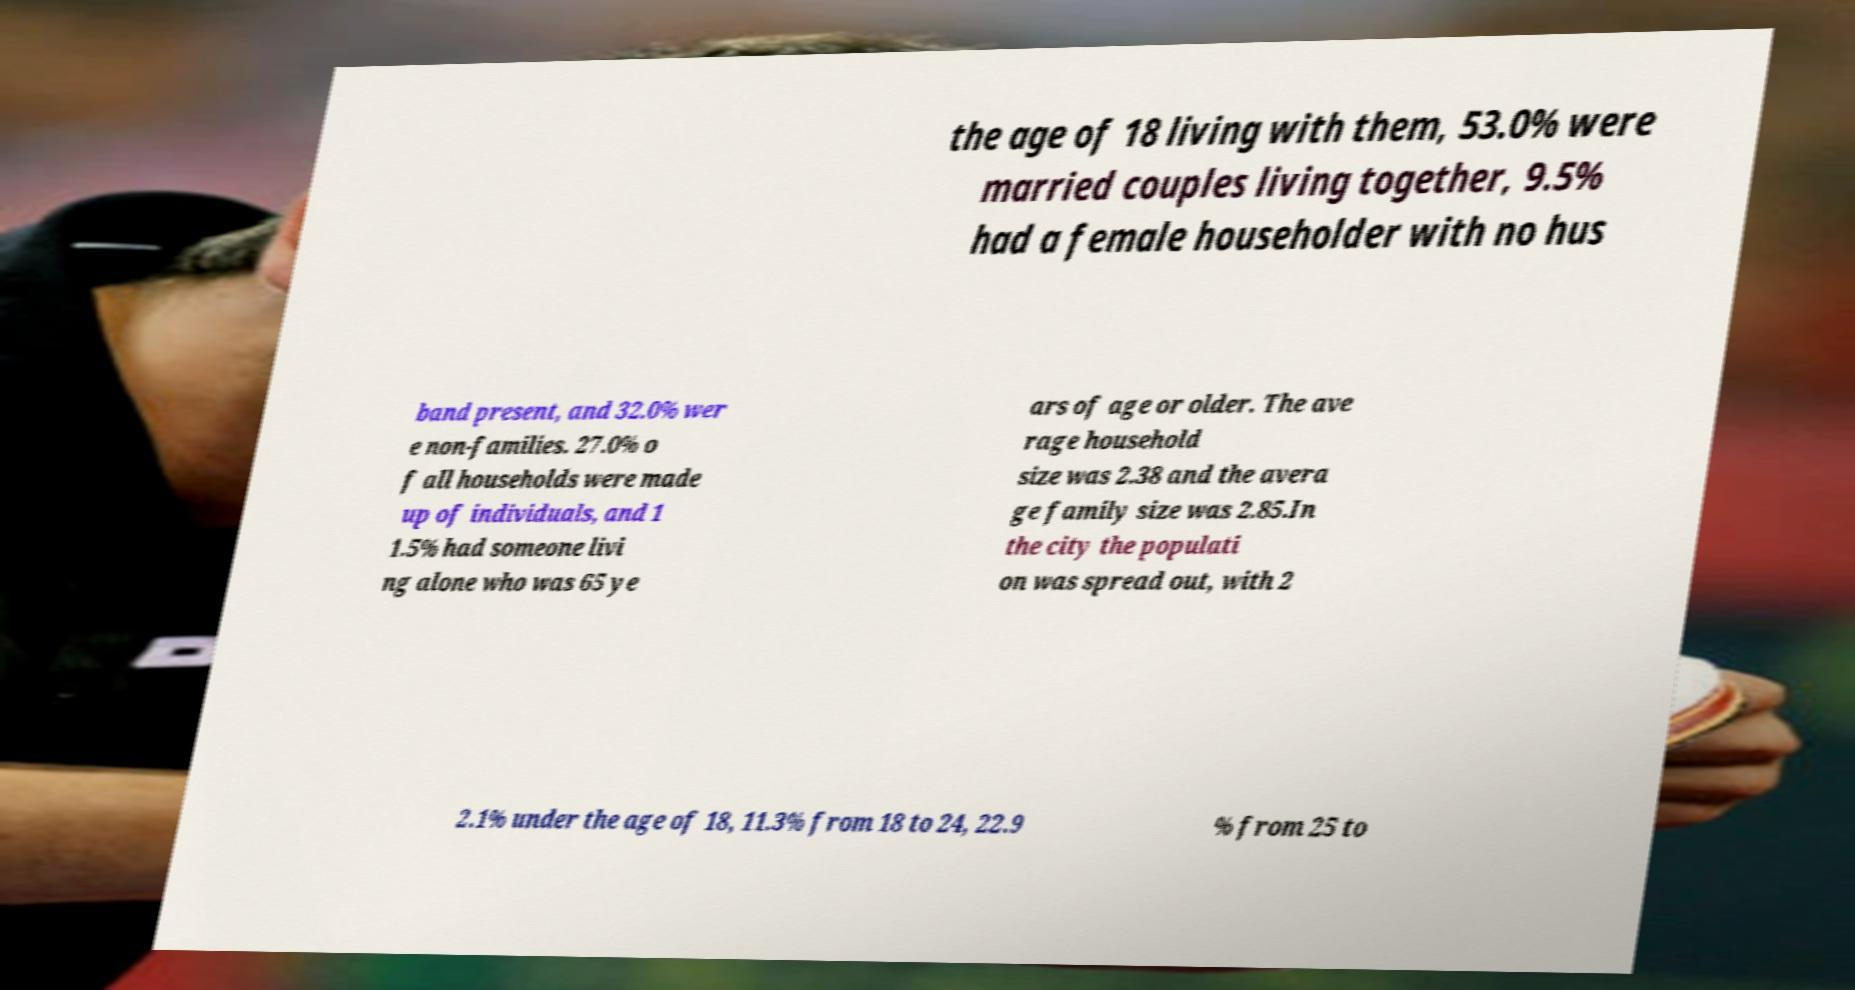I need the written content from this picture converted into text. Can you do that? the age of 18 living with them, 53.0% were married couples living together, 9.5% had a female householder with no hus band present, and 32.0% wer e non-families. 27.0% o f all households were made up of individuals, and 1 1.5% had someone livi ng alone who was 65 ye ars of age or older. The ave rage household size was 2.38 and the avera ge family size was 2.85.In the city the populati on was spread out, with 2 2.1% under the age of 18, 11.3% from 18 to 24, 22.9 % from 25 to 